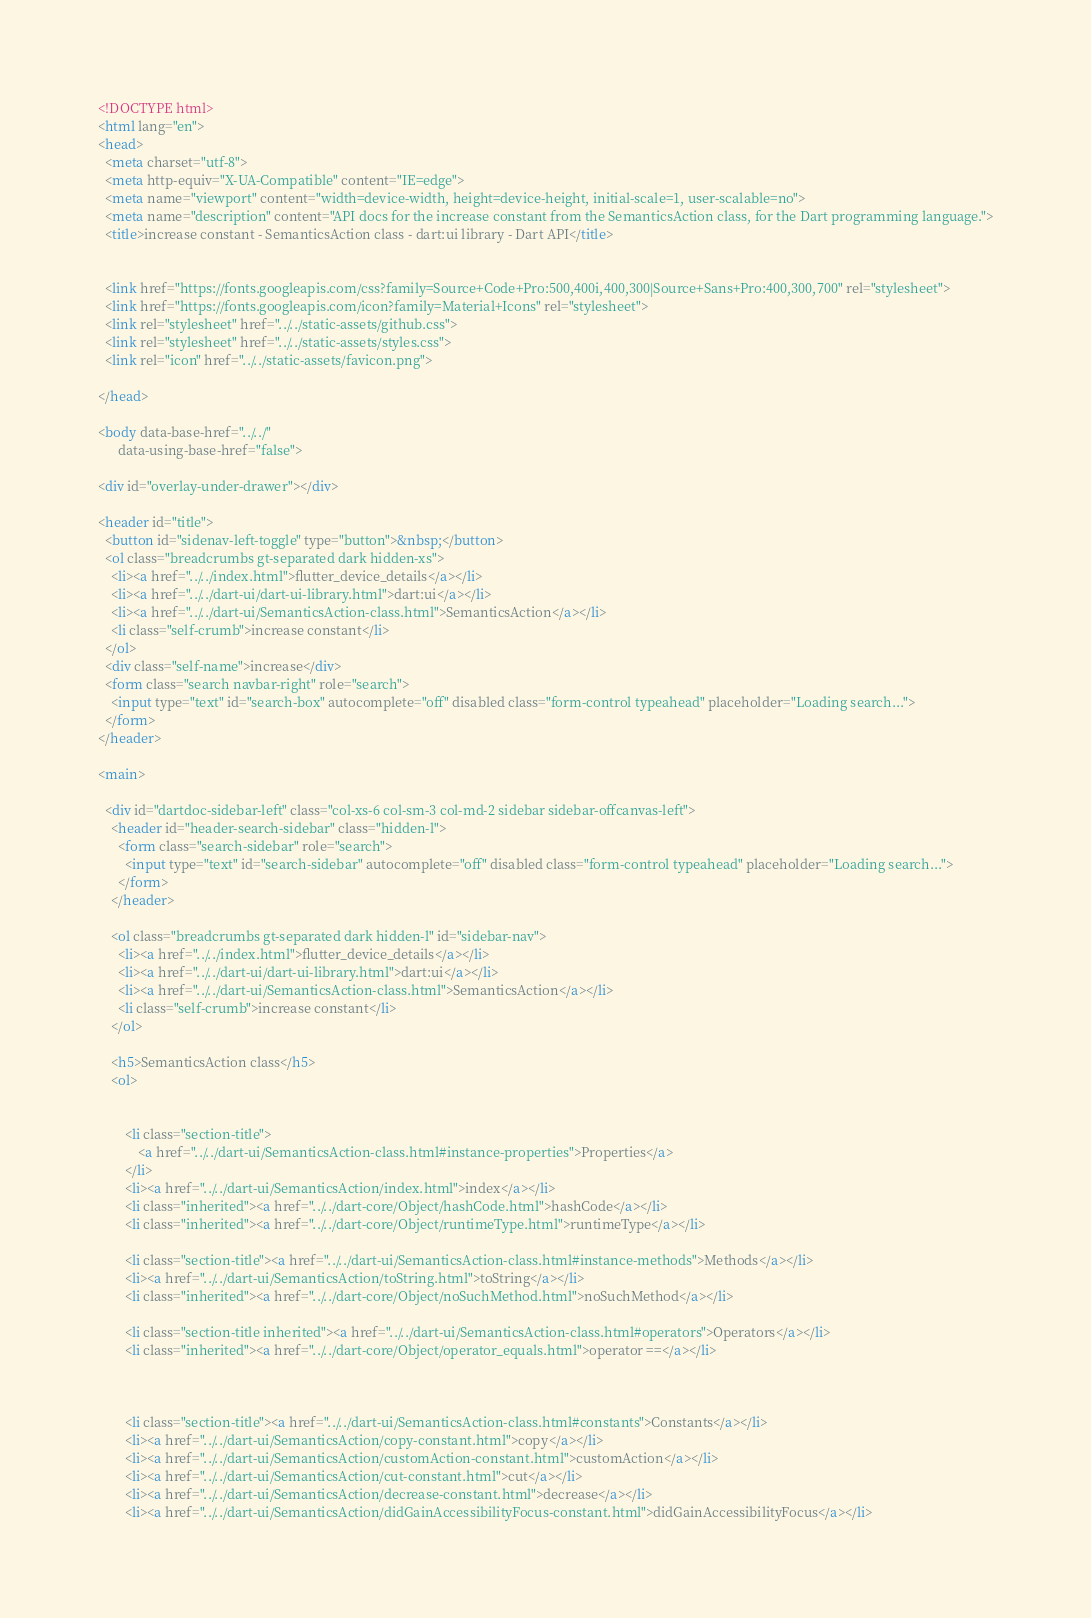Convert code to text. <code><loc_0><loc_0><loc_500><loc_500><_HTML_><!DOCTYPE html>
<html lang="en">
<head>
  <meta charset="utf-8">
  <meta http-equiv="X-UA-Compatible" content="IE=edge">
  <meta name="viewport" content="width=device-width, height=device-height, initial-scale=1, user-scalable=no">
  <meta name="description" content="API docs for the increase constant from the SemanticsAction class, for the Dart programming language.">
  <title>increase constant - SemanticsAction class - dart:ui library - Dart API</title>

  
  <link href="https://fonts.googleapis.com/css?family=Source+Code+Pro:500,400i,400,300|Source+Sans+Pro:400,300,700" rel="stylesheet">
  <link href="https://fonts.googleapis.com/icon?family=Material+Icons" rel="stylesheet">
  <link rel="stylesheet" href="../../static-assets/github.css">
  <link rel="stylesheet" href="../../static-assets/styles.css">
  <link rel="icon" href="../../static-assets/favicon.png">

</head>

<body data-base-href="../../"
      data-using-base-href="false">

<div id="overlay-under-drawer"></div>

<header id="title">
  <button id="sidenav-left-toggle" type="button">&nbsp;</button>
  <ol class="breadcrumbs gt-separated dark hidden-xs">
    <li><a href="../../index.html">flutter_device_details</a></li>
    <li><a href="../../dart-ui/dart-ui-library.html">dart:ui</a></li>
    <li><a href="../../dart-ui/SemanticsAction-class.html">SemanticsAction</a></li>
    <li class="self-crumb">increase constant</li>
  </ol>
  <div class="self-name">increase</div>
  <form class="search navbar-right" role="search">
    <input type="text" id="search-box" autocomplete="off" disabled class="form-control typeahead" placeholder="Loading search...">
  </form>
</header>

<main>

  <div id="dartdoc-sidebar-left" class="col-xs-6 col-sm-3 col-md-2 sidebar sidebar-offcanvas-left">
    <header id="header-search-sidebar" class="hidden-l">
      <form class="search-sidebar" role="search">
        <input type="text" id="search-sidebar" autocomplete="off" disabled class="form-control typeahead" placeholder="Loading search...">
      </form>
    </header>
    
    <ol class="breadcrumbs gt-separated dark hidden-l" id="sidebar-nav">
      <li><a href="../../index.html">flutter_device_details</a></li>
      <li><a href="../../dart-ui/dart-ui-library.html">dart:ui</a></li>
      <li><a href="../../dart-ui/SemanticsAction-class.html">SemanticsAction</a></li>
      <li class="self-crumb">increase constant</li>
    </ol>
    
    <h5>SemanticsAction class</h5>
    <ol>
    
    
        <li class="section-title">
            <a href="../../dart-ui/SemanticsAction-class.html#instance-properties">Properties</a>
        </li>
        <li><a href="../../dart-ui/SemanticsAction/index.html">index</a></li>
        <li class="inherited"><a href="../../dart-core/Object/hashCode.html">hashCode</a></li>
        <li class="inherited"><a href="../../dart-core/Object/runtimeType.html">runtimeType</a></li>
    
        <li class="section-title"><a href="../../dart-ui/SemanticsAction-class.html#instance-methods">Methods</a></li>
        <li><a href="../../dart-ui/SemanticsAction/toString.html">toString</a></li>
        <li class="inherited"><a href="../../dart-core/Object/noSuchMethod.html">noSuchMethod</a></li>
    
        <li class="section-title inherited"><a href="../../dart-ui/SemanticsAction-class.html#operators">Operators</a></li>
        <li class="inherited"><a href="../../dart-core/Object/operator_equals.html">operator ==</a></li>
    
    
    
        <li class="section-title"><a href="../../dart-ui/SemanticsAction-class.html#constants">Constants</a></li>
        <li><a href="../../dart-ui/SemanticsAction/copy-constant.html">copy</a></li>
        <li><a href="../../dart-ui/SemanticsAction/customAction-constant.html">customAction</a></li>
        <li><a href="../../dart-ui/SemanticsAction/cut-constant.html">cut</a></li>
        <li><a href="../../dart-ui/SemanticsAction/decrease-constant.html">decrease</a></li>
        <li><a href="../../dart-ui/SemanticsAction/didGainAccessibilityFocus-constant.html">didGainAccessibilityFocus</a></li></code> 